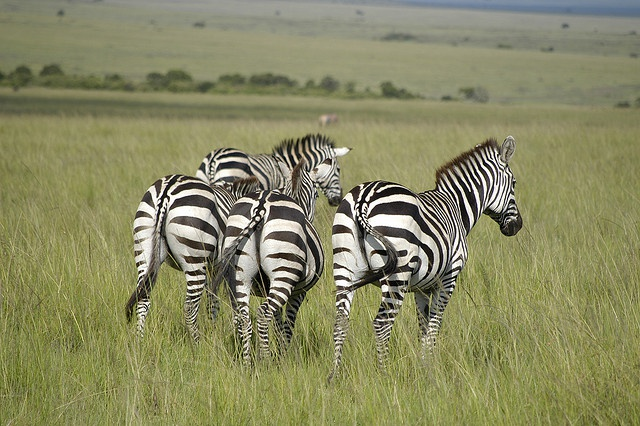Describe the objects in this image and their specific colors. I can see zebra in gray, black, ivory, and darkgray tones, zebra in gray, black, ivory, and darkgray tones, zebra in gray, ivory, black, and darkgray tones, and zebra in gray, black, darkgray, and ivory tones in this image. 